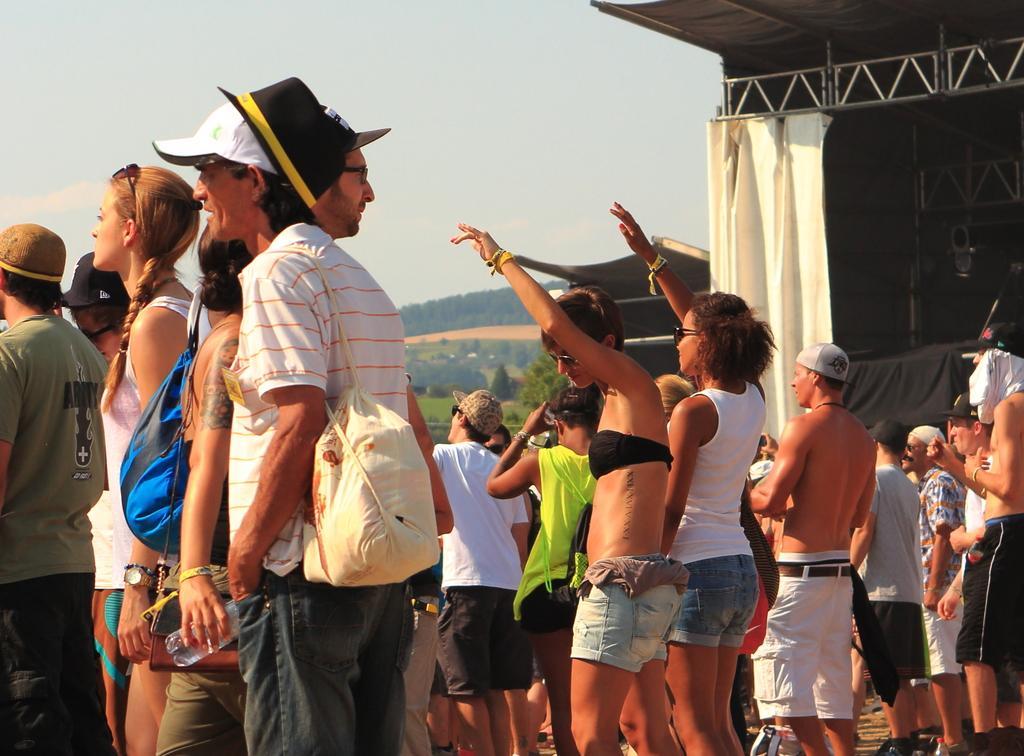Could you give a brief overview of what you see in this image? In this image I can see group of people standing, the person in front wearing white shirt, black pant and I can also see a blue color bag. Background I can see a curtain in white color, trees in green color and a building in white color. 